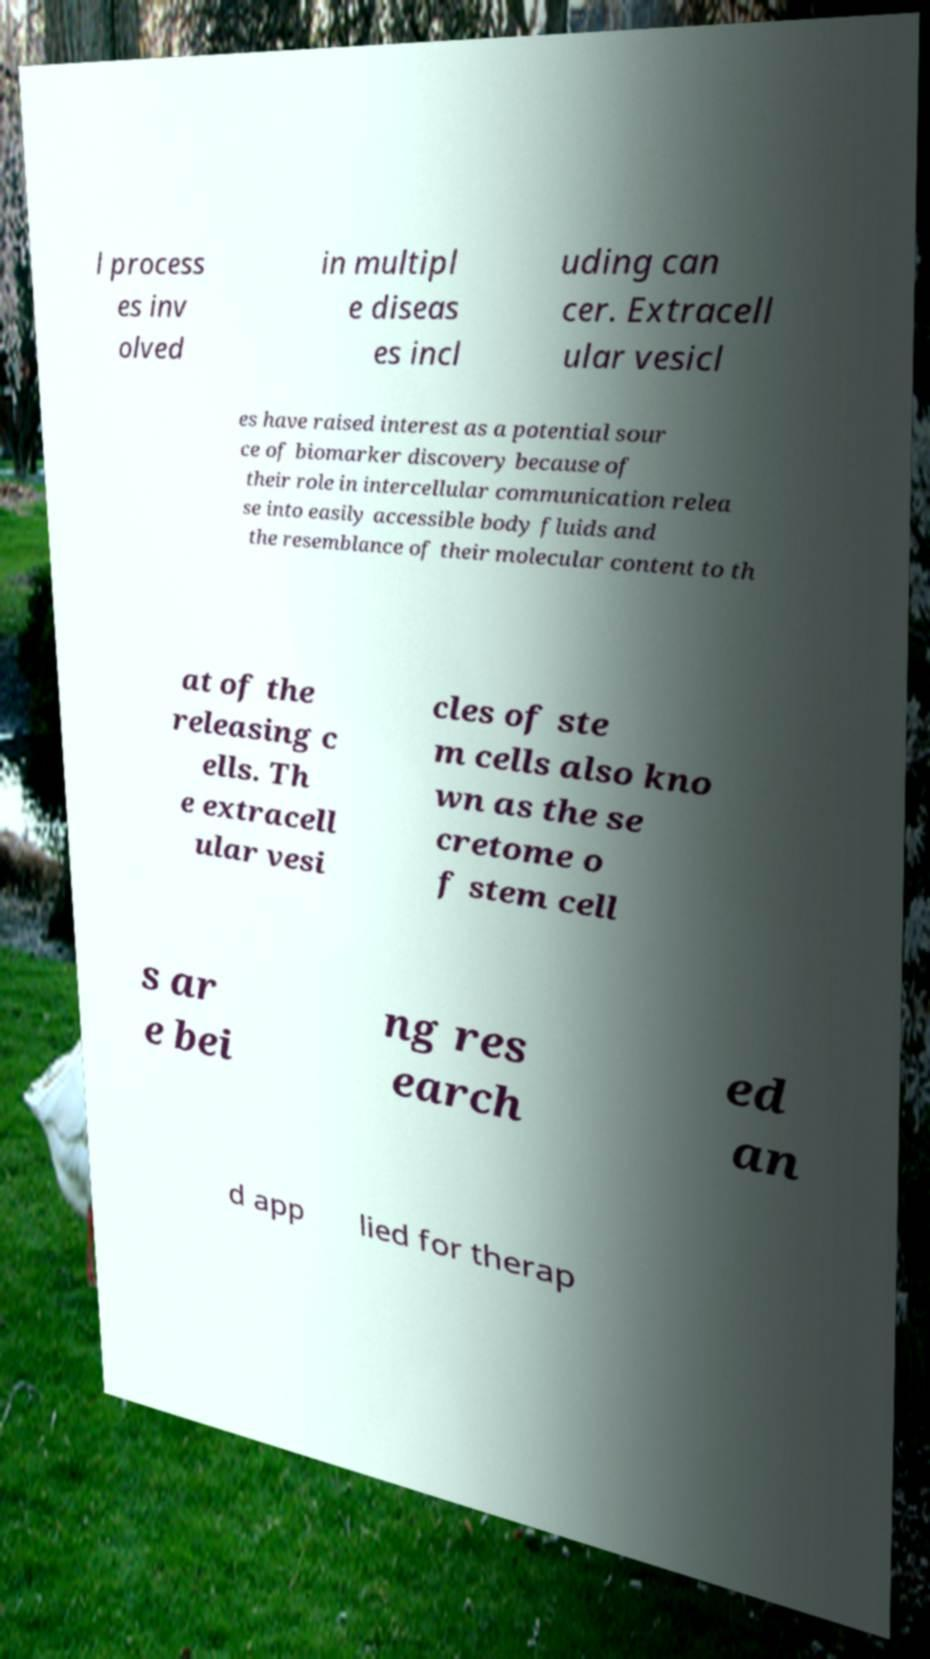Could you assist in decoding the text presented in this image and type it out clearly? l process es inv olved in multipl e diseas es incl uding can cer. Extracell ular vesicl es have raised interest as a potential sour ce of biomarker discovery because of their role in intercellular communication relea se into easily accessible body fluids and the resemblance of their molecular content to th at of the releasing c ells. Th e extracell ular vesi cles of ste m cells also kno wn as the se cretome o f stem cell s ar e bei ng res earch ed an d app lied for therap 